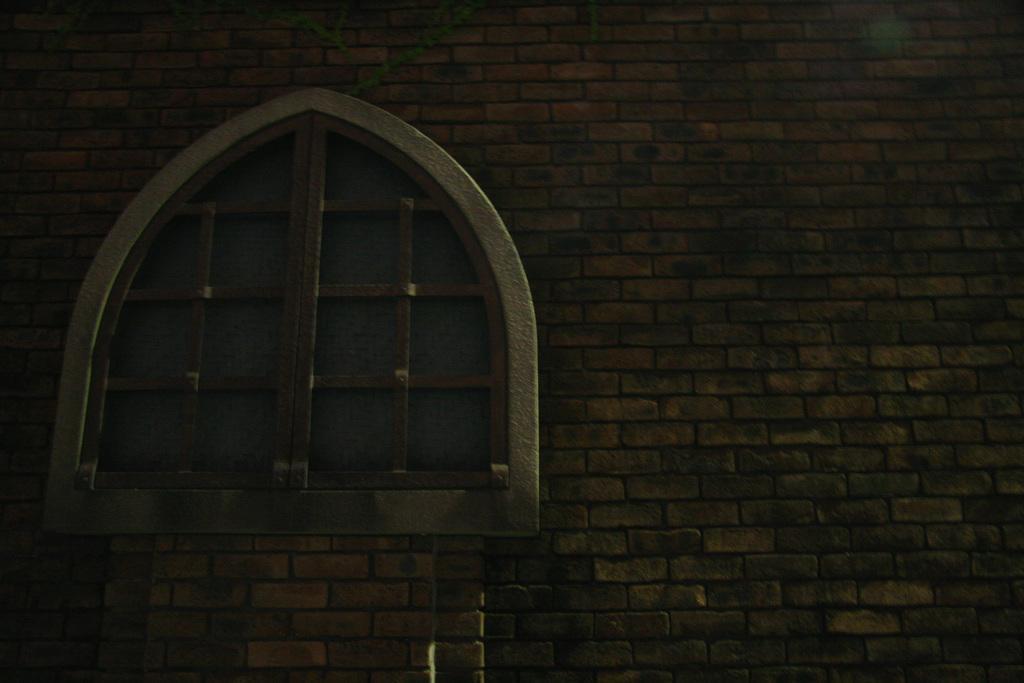Could you give a brief overview of what you see in this image? In this image, we can see a window to a wall and at the top, there are creepers. 